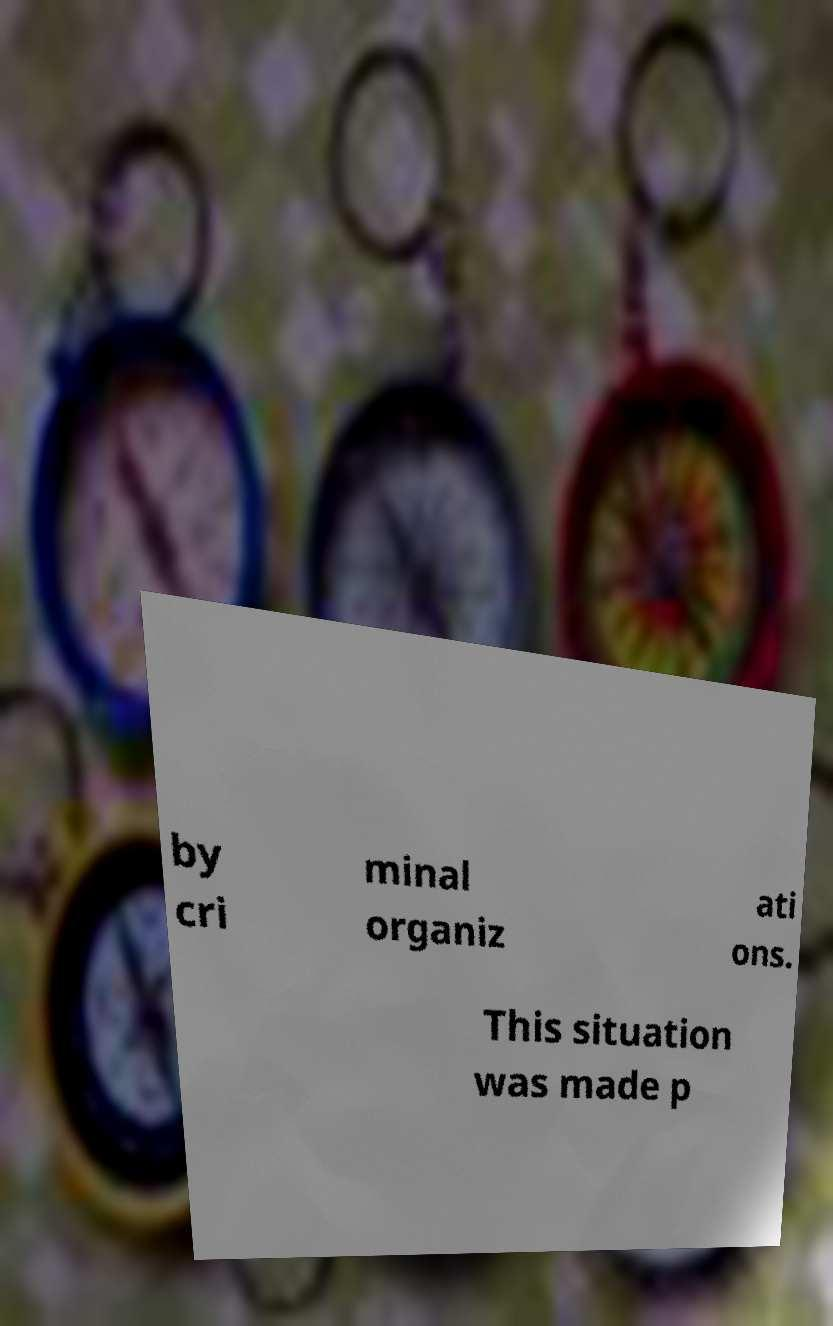There's text embedded in this image that I need extracted. Can you transcribe it verbatim? by cri minal organiz ati ons. This situation was made p 